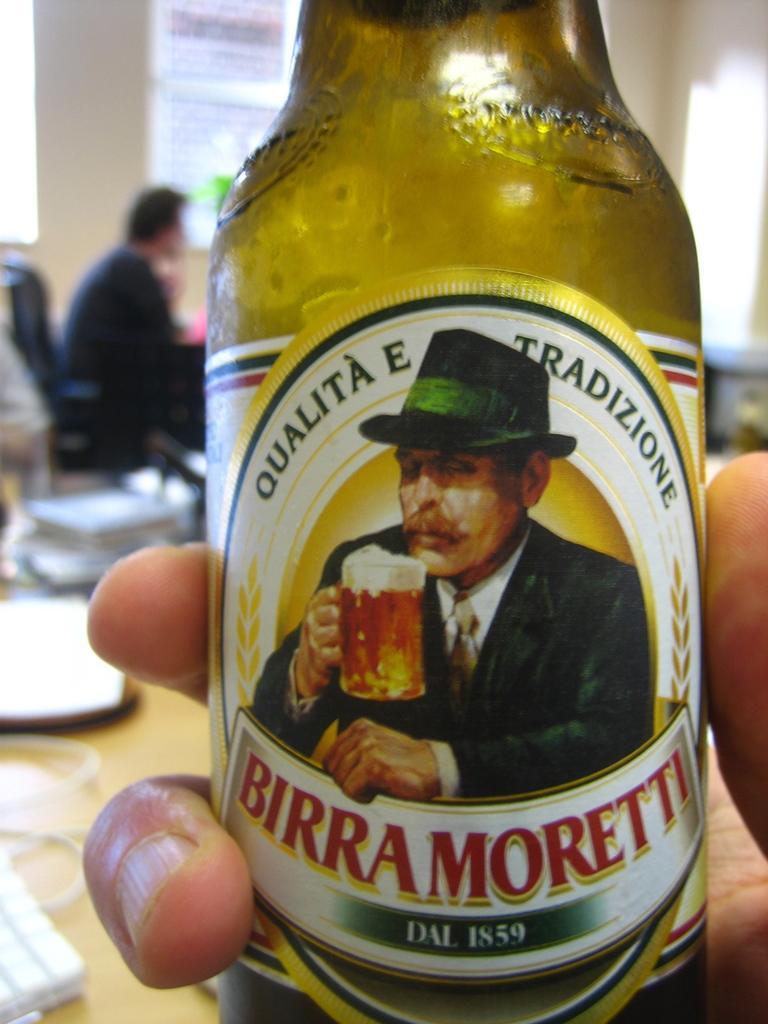How would you summarize this image in a sentence or two? this picture is consists of a cool drink bottle, which is placed in some ones hand the word which is written on the bottle is birra moretti. 